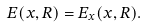<formula> <loc_0><loc_0><loc_500><loc_500>E ( x , R ) = E _ { x } ( x , R ) .</formula> 